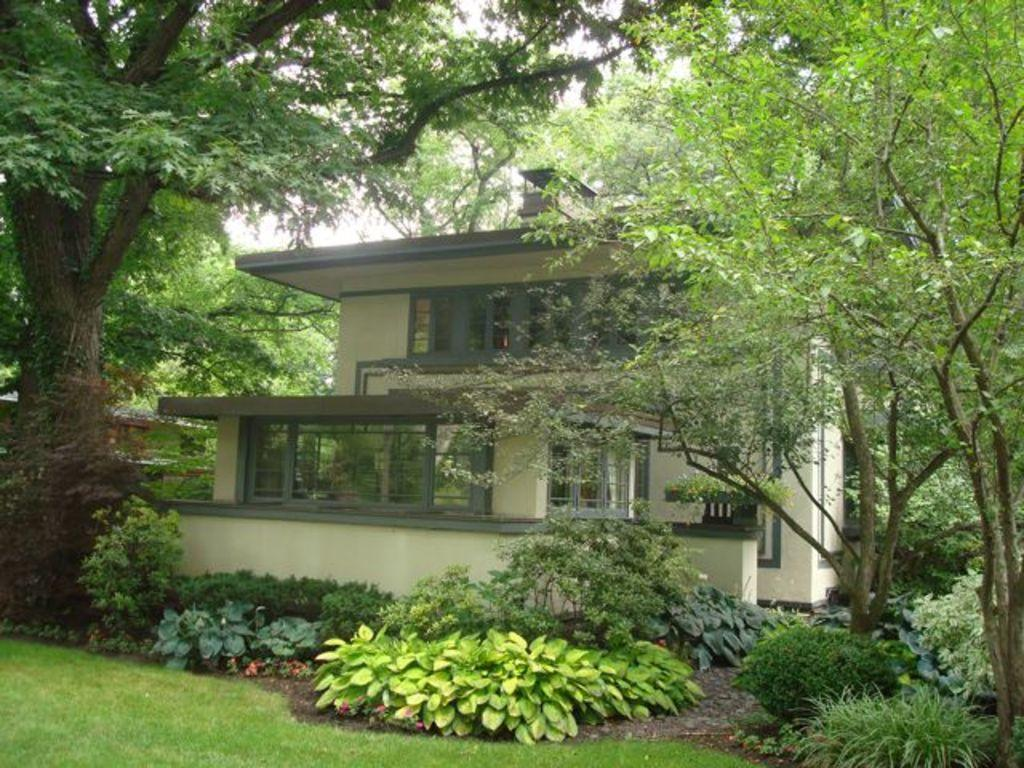What type of structures can be seen in the image? There are buildings in the image. What type of vegetation is present in the image? Shrubs and bushes are visible in the image, as well as trees. What part of the natural environment is visible in the image? The sky is visible in the image. What type of curtain can be seen hanging from the trees in the image? There are no curtains present in the image; it features buildings, vegetation, and the sky. Can you see anyone kicking a soccer ball in the image? There is no soccer ball or person kicking it visible in the image. 